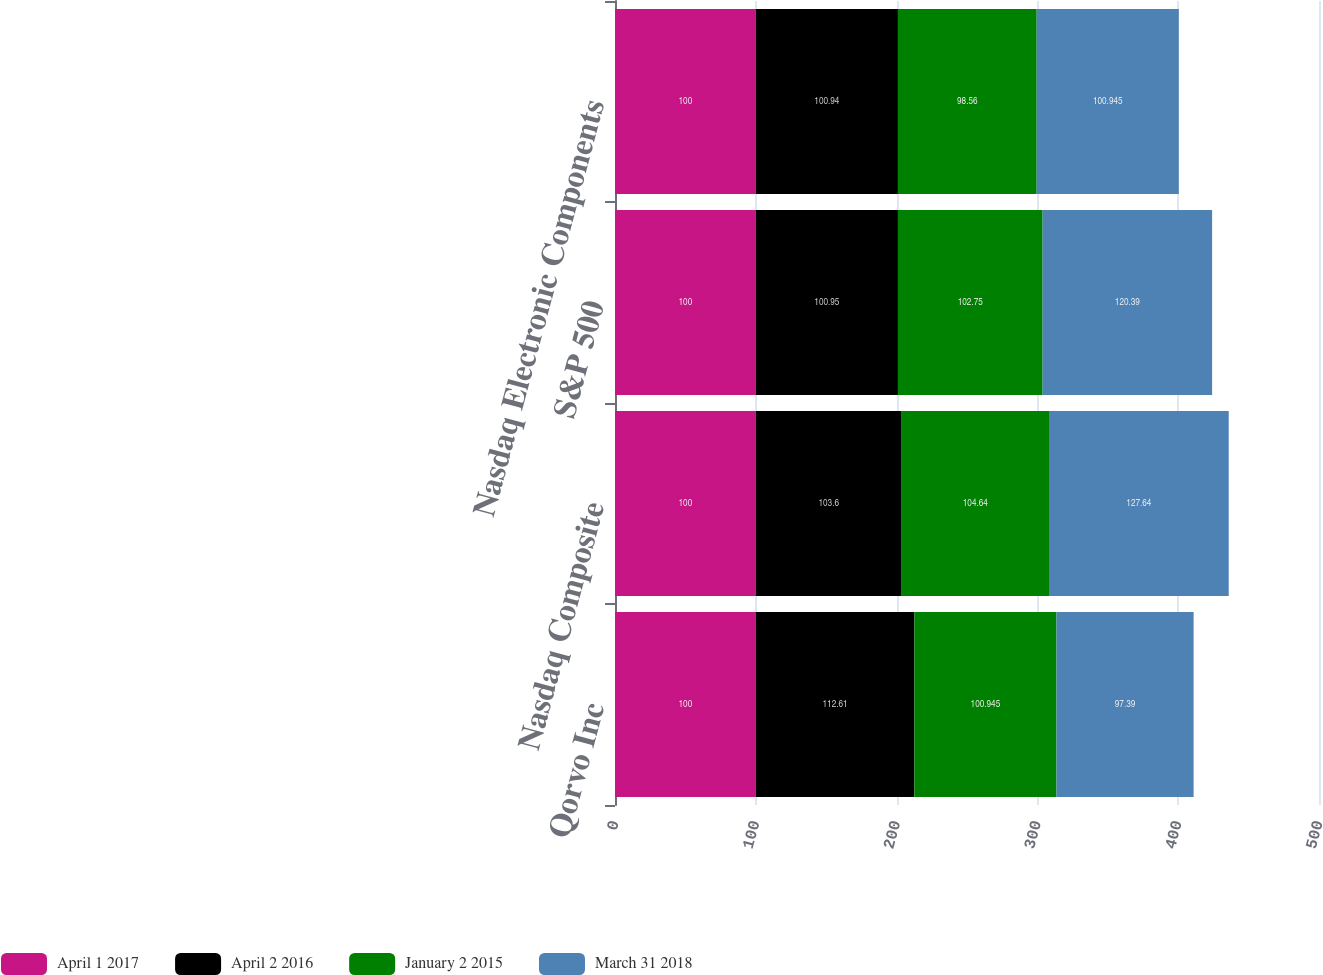Convert chart. <chart><loc_0><loc_0><loc_500><loc_500><stacked_bar_chart><ecel><fcel>Qorvo Inc<fcel>Nasdaq Composite<fcel>S&P 500<fcel>Nasdaq Electronic Components<nl><fcel>April 1 2017<fcel>100<fcel>100<fcel>100<fcel>100<nl><fcel>April 2 2016<fcel>112.61<fcel>103.6<fcel>100.95<fcel>100.94<nl><fcel>January 2 2015<fcel>100.945<fcel>104.64<fcel>102.75<fcel>98.56<nl><fcel>March 31 2018<fcel>97.39<fcel>127.64<fcel>120.39<fcel>100.945<nl></chart> 